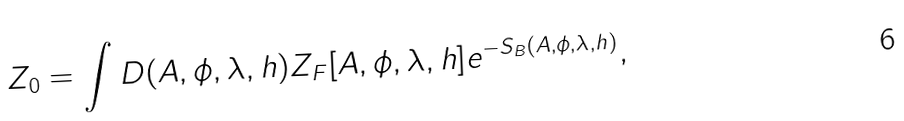Convert formula to latex. <formula><loc_0><loc_0><loc_500><loc_500>Z _ { 0 } = \int D ( A , \phi , \lambda , h ) Z _ { F } [ A , \phi , \lambda , h ] e ^ { - S _ { B } ( A , \phi , \lambda , h ) } ,</formula> 